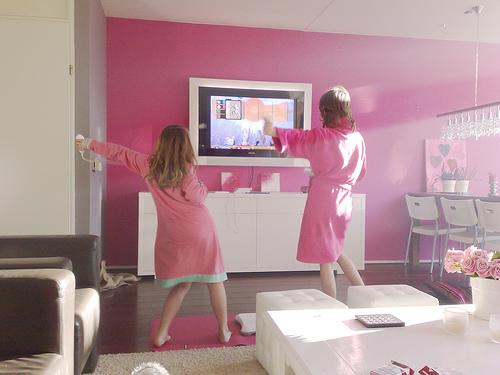What is featured by the TV?

Choices:
A) dolls
B) dancing show
C) video game
D) workout video game 